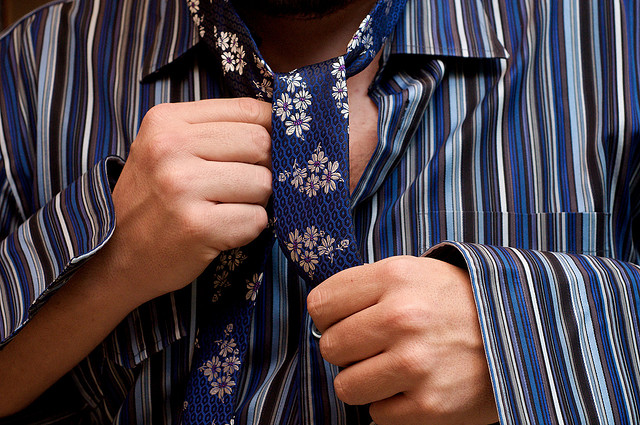<image>Is this person about to attend a conservative gathering? It is unknown whether the person is about to attend a conservative gathering. Is this person about to attend a conservative gathering? I don't know if this person is about to attend a conservative gathering. It is uncertain based on the given information. 